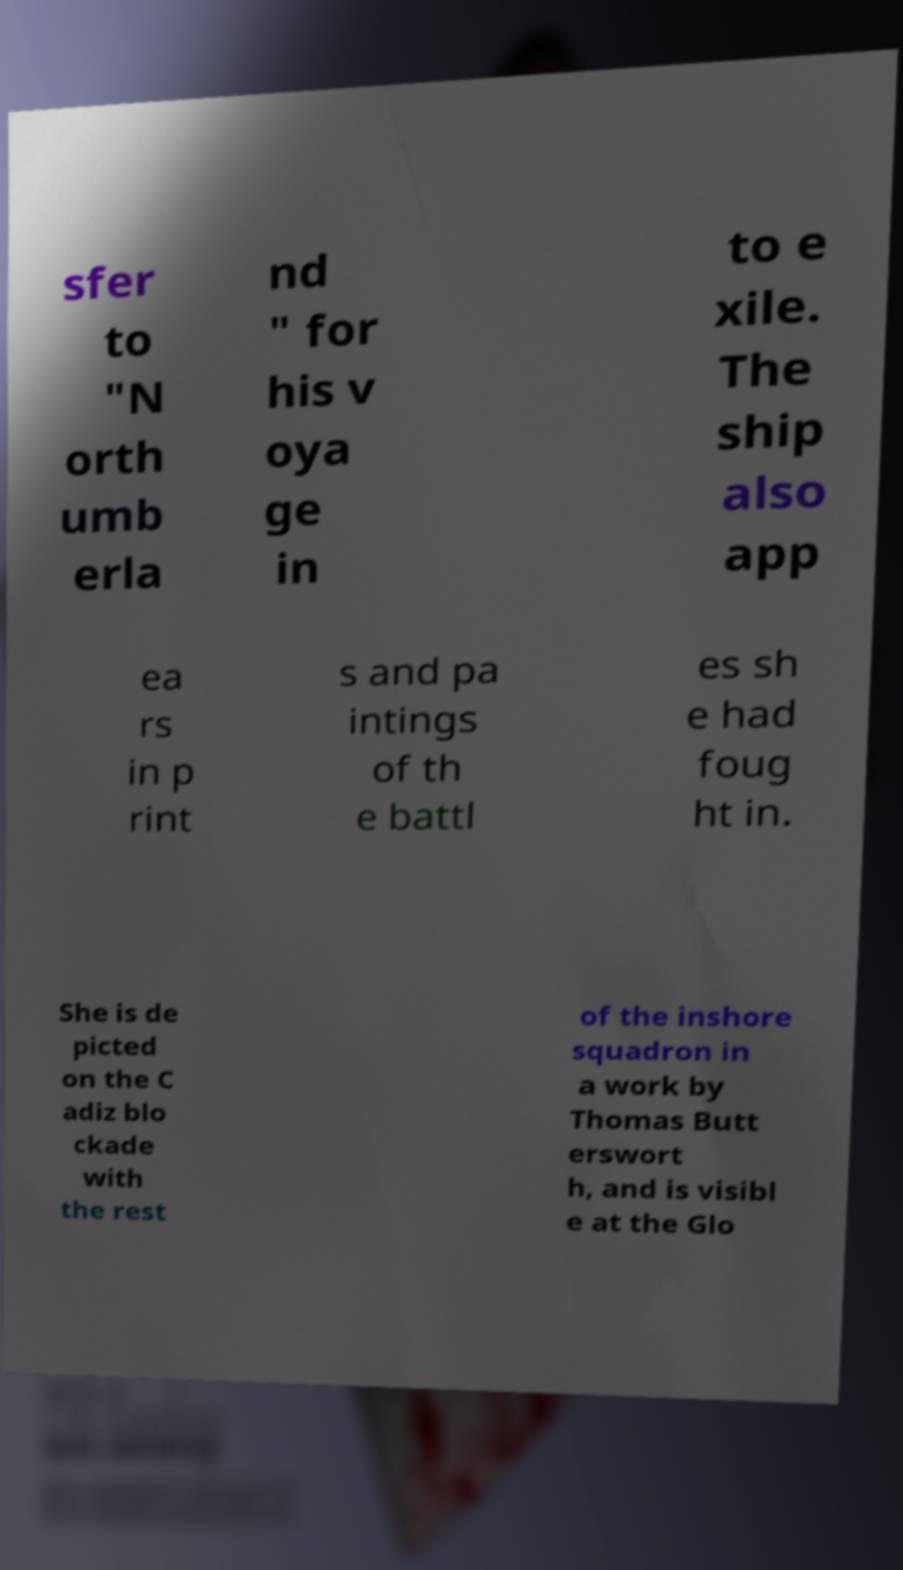There's text embedded in this image that I need extracted. Can you transcribe it verbatim? sfer to "N orth umb erla nd " for his v oya ge in to e xile. The ship also app ea rs in p rint s and pa intings of th e battl es sh e had foug ht in. She is de picted on the C adiz blo ckade with the rest of the inshore squadron in a work by Thomas Butt erswort h, and is visibl e at the Glo 